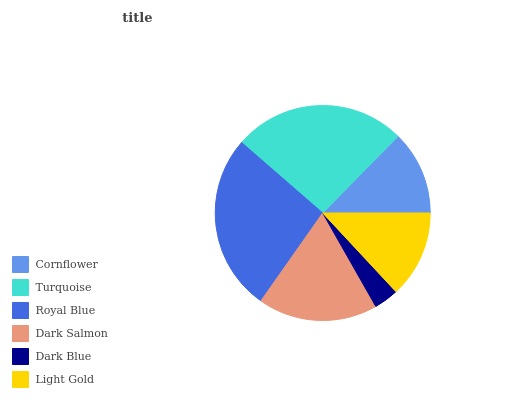Is Dark Blue the minimum?
Answer yes or no. Yes. Is Royal Blue the maximum?
Answer yes or no. Yes. Is Turquoise the minimum?
Answer yes or no. No. Is Turquoise the maximum?
Answer yes or no. No. Is Turquoise greater than Cornflower?
Answer yes or no. Yes. Is Cornflower less than Turquoise?
Answer yes or no. Yes. Is Cornflower greater than Turquoise?
Answer yes or no. No. Is Turquoise less than Cornflower?
Answer yes or no. No. Is Dark Salmon the high median?
Answer yes or no. Yes. Is Light Gold the low median?
Answer yes or no. Yes. Is Light Gold the high median?
Answer yes or no. No. Is Dark Salmon the low median?
Answer yes or no. No. 